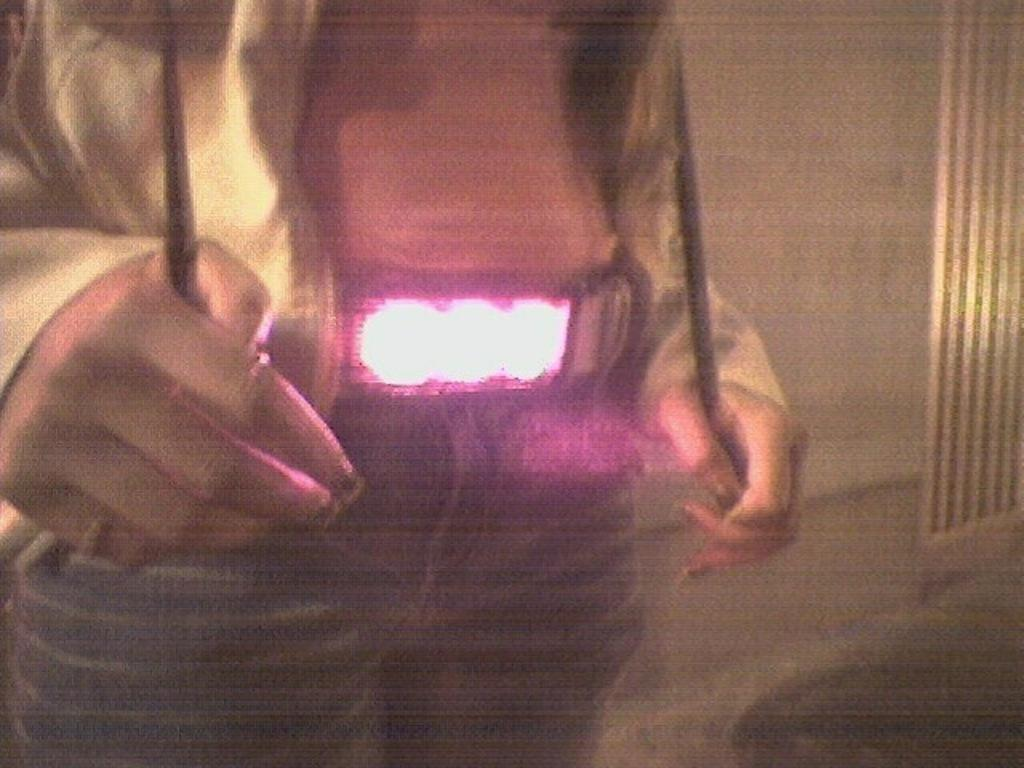What is the main subject in the foreground of the image? There is a person in the foreground of the image. What type of clothing is the person wearing? The person is wearing jeans and a jacket. What can be seen in the background of the image? There is a wall in the background of the image. How many books are on the cook's shelf in the image? There is no cook or shelf with books present in the image. 